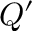Convert formula to latex. <formula><loc_0><loc_0><loc_500><loc_500>Q ^ { \prime }</formula> 